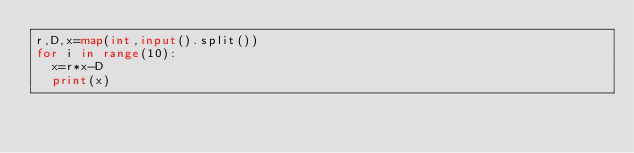Convert code to text. <code><loc_0><loc_0><loc_500><loc_500><_Python_>r,D,x=map(int,input().split())
for i in range(10):
  x=r*x-D
  print(x)</code> 